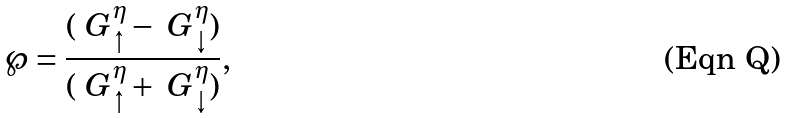<formula> <loc_0><loc_0><loc_500><loc_500>\wp = \frac { ( \ G _ { \uparrow } ^ { \eta } - \ G _ { \downarrow } ^ { \eta } ) } { ( \ G _ { \uparrow } ^ { \eta } + \ G _ { \downarrow } ^ { \eta } ) } ,</formula> 